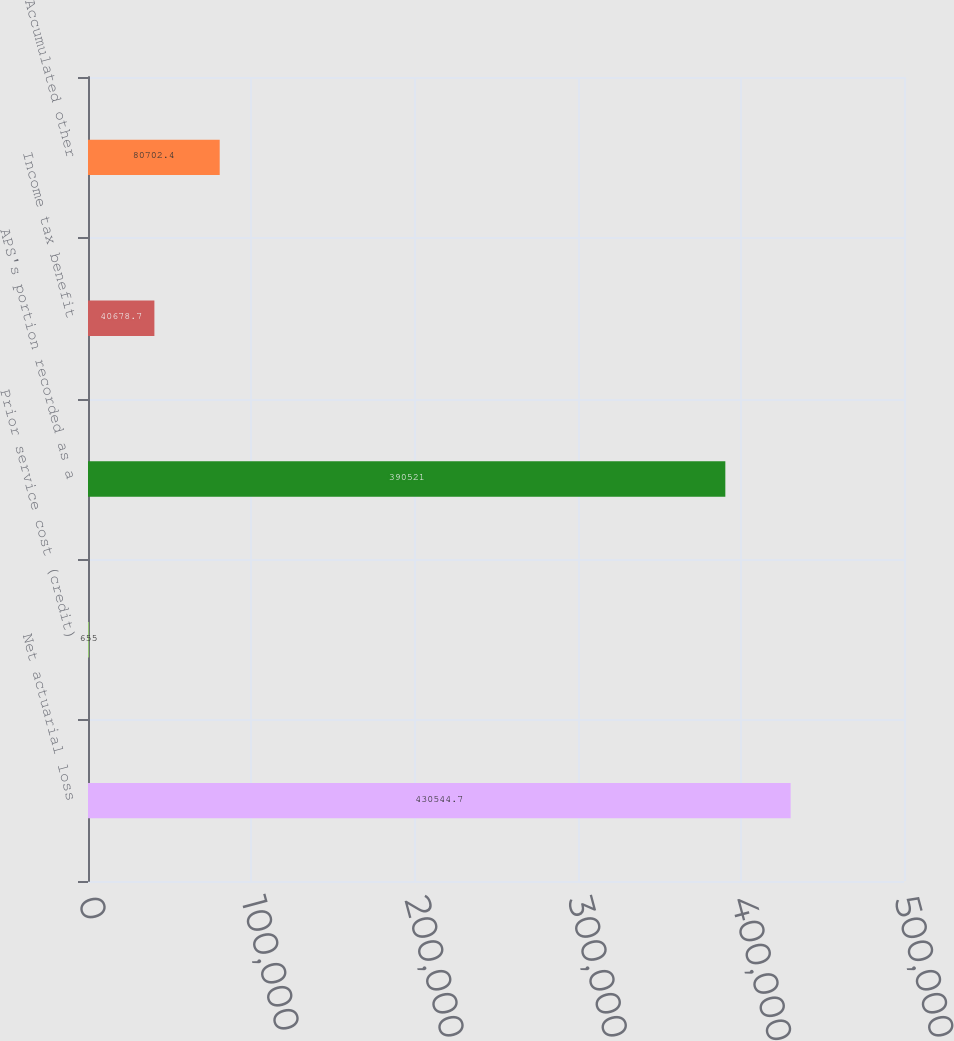Convert chart to OTSL. <chart><loc_0><loc_0><loc_500><loc_500><bar_chart><fcel>Net actuarial loss<fcel>Prior service cost (credit)<fcel>APS's portion recorded as a<fcel>Income tax benefit<fcel>Accumulated other<nl><fcel>430545<fcel>655<fcel>390521<fcel>40678.7<fcel>80702.4<nl></chart> 